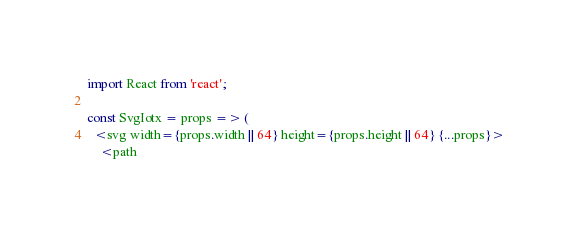Convert code to text. <code><loc_0><loc_0><loc_500><loc_500><_JavaScript_>import React from 'react';

const SvgIotx = props => (
  <svg width={props.width || 64} height={props.height || 64} {...props}>
    <path</code> 